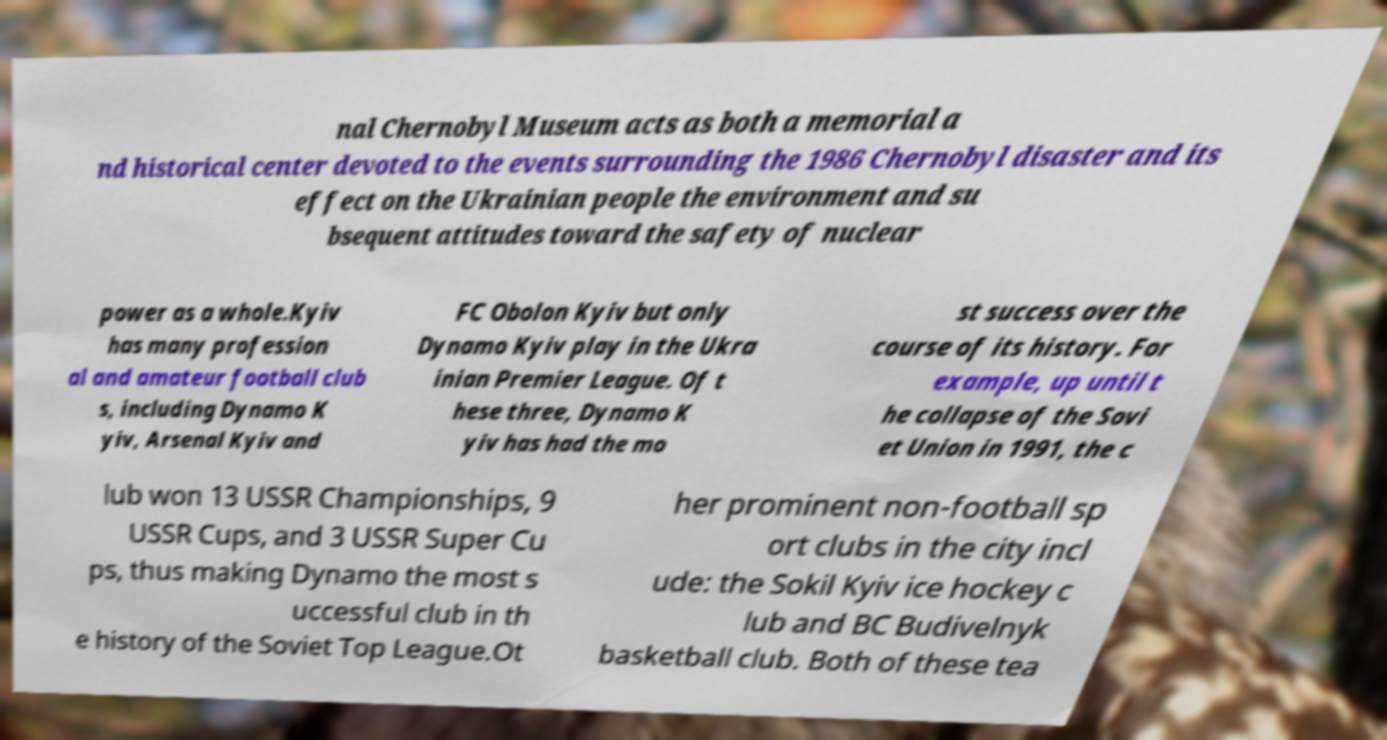There's text embedded in this image that I need extracted. Can you transcribe it verbatim? nal Chernobyl Museum acts as both a memorial a nd historical center devoted to the events surrounding the 1986 Chernobyl disaster and its effect on the Ukrainian people the environment and su bsequent attitudes toward the safety of nuclear power as a whole.Kyiv has many profession al and amateur football club s, including Dynamo K yiv, Arsenal Kyiv and FC Obolon Kyiv but only Dynamo Kyiv play in the Ukra inian Premier League. Of t hese three, Dynamo K yiv has had the mo st success over the course of its history. For example, up until t he collapse of the Sovi et Union in 1991, the c lub won 13 USSR Championships, 9 USSR Cups, and 3 USSR Super Cu ps, thus making Dynamo the most s uccessful club in th e history of the Soviet Top League.Ot her prominent non-football sp ort clubs in the city incl ude: the Sokil Kyiv ice hockey c lub and BC Budivelnyk basketball club. Both of these tea 